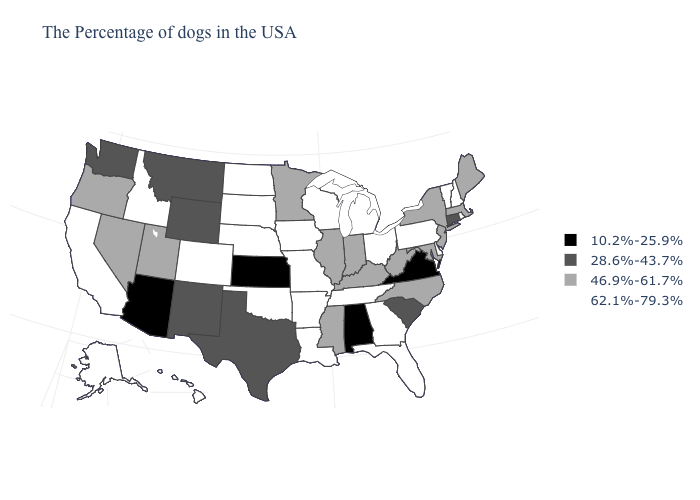Which states hav the highest value in the MidWest?
Answer briefly. Ohio, Michigan, Wisconsin, Missouri, Iowa, Nebraska, South Dakota, North Dakota. What is the value of West Virginia?
Quick response, please. 46.9%-61.7%. Name the states that have a value in the range 62.1%-79.3%?
Be succinct. Rhode Island, New Hampshire, Vermont, Delaware, Pennsylvania, Ohio, Florida, Georgia, Michigan, Tennessee, Wisconsin, Louisiana, Missouri, Arkansas, Iowa, Nebraska, Oklahoma, South Dakota, North Dakota, Colorado, Idaho, California, Alaska, Hawaii. Does Mississippi have the same value as New Hampshire?
Give a very brief answer. No. What is the value of Washington?
Concise answer only. 28.6%-43.7%. What is the value of Arkansas?
Concise answer only. 62.1%-79.3%. Does Maryland have a higher value than Connecticut?
Keep it brief. Yes. Does North Carolina have the highest value in the USA?
Keep it brief. No. Name the states that have a value in the range 28.6%-43.7%?
Give a very brief answer. Connecticut, South Carolina, Texas, Wyoming, New Mexico, Montana, Washington. What is the lowest value in the USA?
Answer briefly. 10.2%-25.9%. Name the states that have a value in the range 28.6%-43.7%?
Answer briefly. Connecticut, South Carolina, Texas, Wyoming, New Mexico, Montana, Washington. How many symbols are there in the legend?
Short answer required. 4. Which states have the highest value in the USA?
Short answer required. Rhode Island, New Hampshire, Vermont, Delaware, Pennsylvania, Ohio, Florida, Georgia, Michigan, Tennessee, Wisconsin, Louisiana, Missouri, Arkansas, Iowa, Nebraska, Oklahoma, South Dakota, North Dakota, Colorado, Idaho, California, Alaska, Hawaii. Name the states that have a value in the range 62.1%-79.3%?
Answer briefly. Rhode Island, New Hampshire, Vermont, Delaware, Pennsylvania, Ohio, Florida, Georgia, Michigan, Tennessee, Wisconsin, Louisiana, Missouri, Arkansas, Iowa, Nebraska, Oklahoma, South Dakota, North Dakota, Colorado, Idaho, California, Alaska, Hawaii. What is the value of Maryland?
Answer briefly. 46.9%-61.7%. 